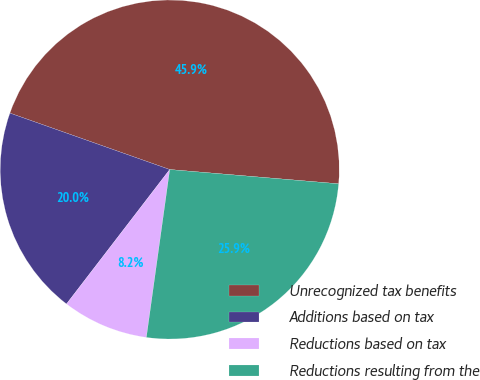Convert chart to OTSL. <chart><loc_0><loc_0><loc_500><loc_500><pie_chart><fcel>Unrecognized tax benefits<fcel>Additions based on tax<fcel>Reductions based on tax<fcel>Reductions resulting from the<nl><fcel>45.94%<fcel>19.98%<fcel>8.22%<fcel>25.86%<nl></chart> 